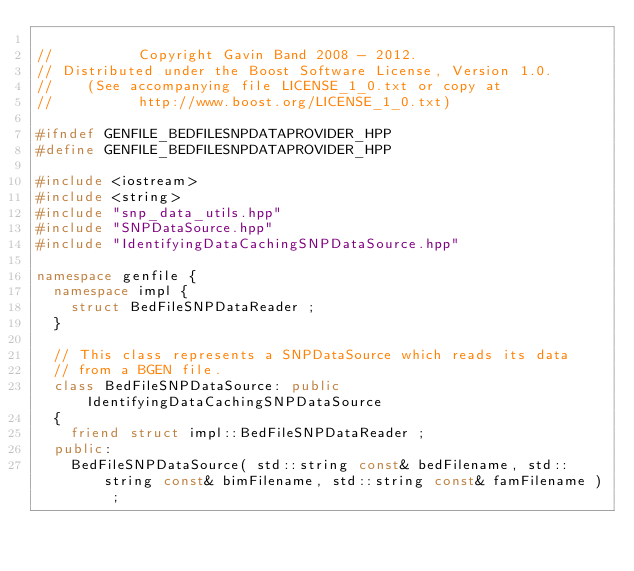<code> <loc_0><loc_0><loc_500><loc_500><_C++_>
//          Copyright Gavin Band 2008 - 2012.
// Distributed under the Boost Software License, Version 1.0.
//    (See accompanying file LICENSE_1_0.txt or copy at
//          http://www.boost.org/LICENSE_1_0.txt)

#ifndef GENFILE_BEDFILESNPDATAPROVIDER_HPP
#define GENFILE_BEDFILESNPDATAPROVIDER_HPP

#include <iostream>
#include <string>
#include "snp_data_utils.hpp"
#include "SNPDataSource.hpp"
#include "IdentifyingDataCachingSNPDataSource.hpp"

namespace genfile {
	namespace impl {
		struct BedFileSNPDataReader ;
	}

	// This class represents a SNPDataSource which reads its data
	// from a BGEN file.
	class BedFileSNPDataSource: public IdentifyingDataCachingSNPDataSource
	{
		friend struct impl::BedFileSNPDataReader ;
	public:
		BedFileSNPDataSource( std::string const& bedFilename, std::string const& bimFilename, std::string const& famFilename ) ;
</code> 